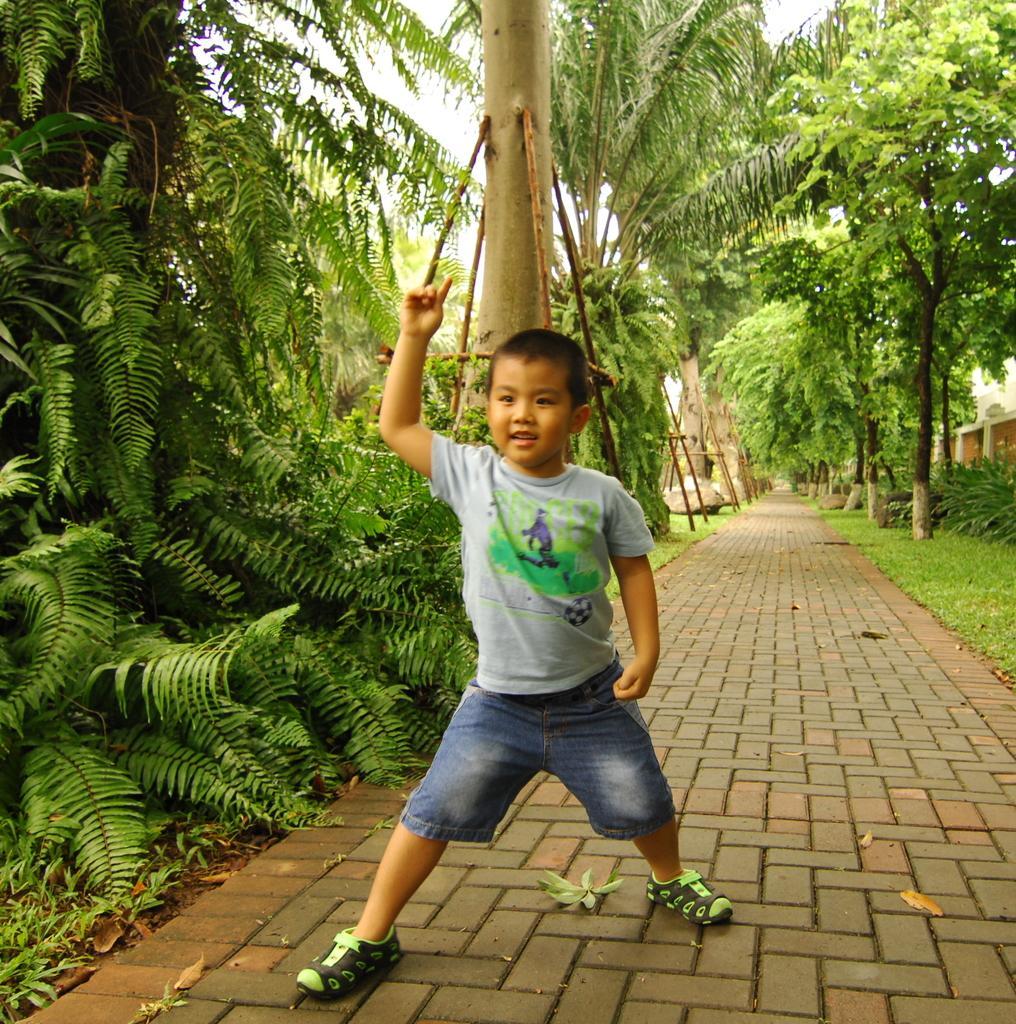Could you give a brief overview of what you see in this image? In the center of the image we can see one kid is standing on the road and he is smiling, which we can see on his face. In the background, we can see the sky, clouds, trees, plants, grass, pole type structures, compound wall and a few other objects. 